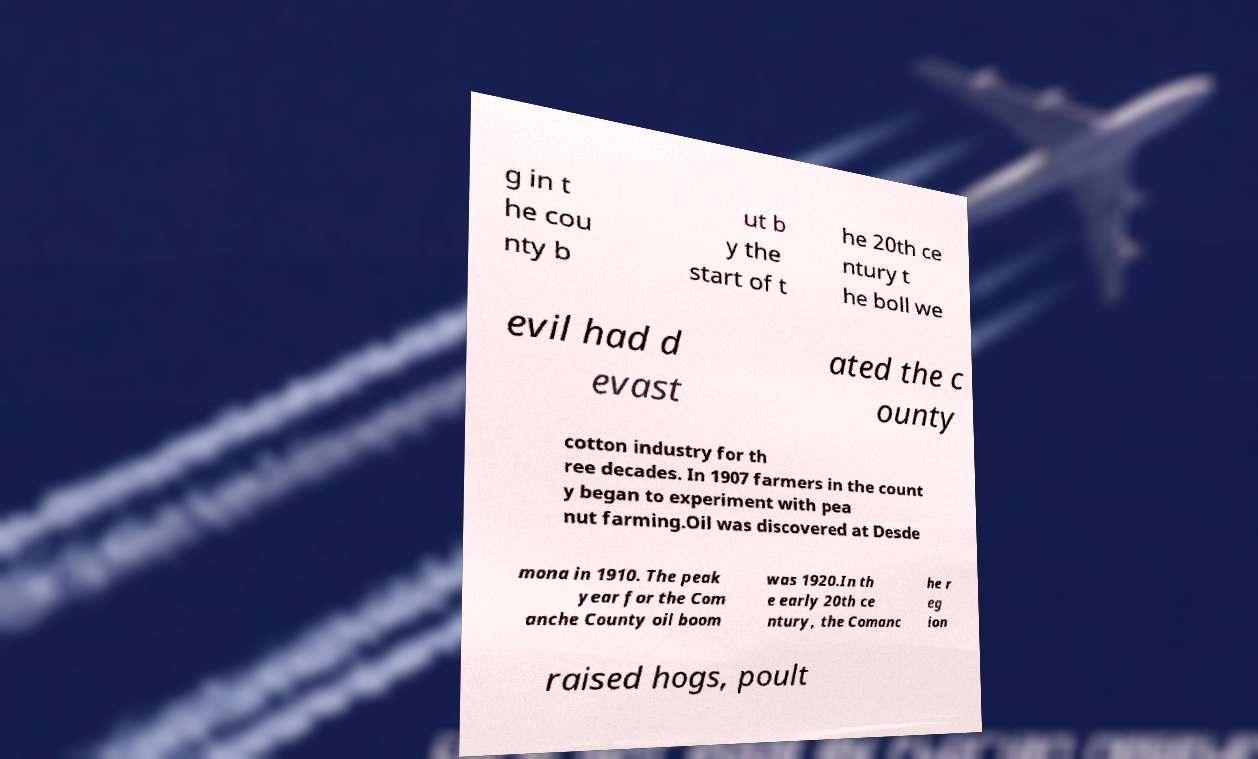I need the written content from this picture converted into text. Can you do that? g in t he cou nty b ut b y the start of t he 20th ce ntury t he boll we evil had d evast ated the c ounty cotton industry for th ree decades. In 1907 farmers in the count y began to experiment with pea nut farming.Oil was discovered at Desde mona in 1910. The peak year for the Com anche County oil boom was 1920.In th e early 20th ce ntury, the Comanc he r eg ion raised hogs, poult 